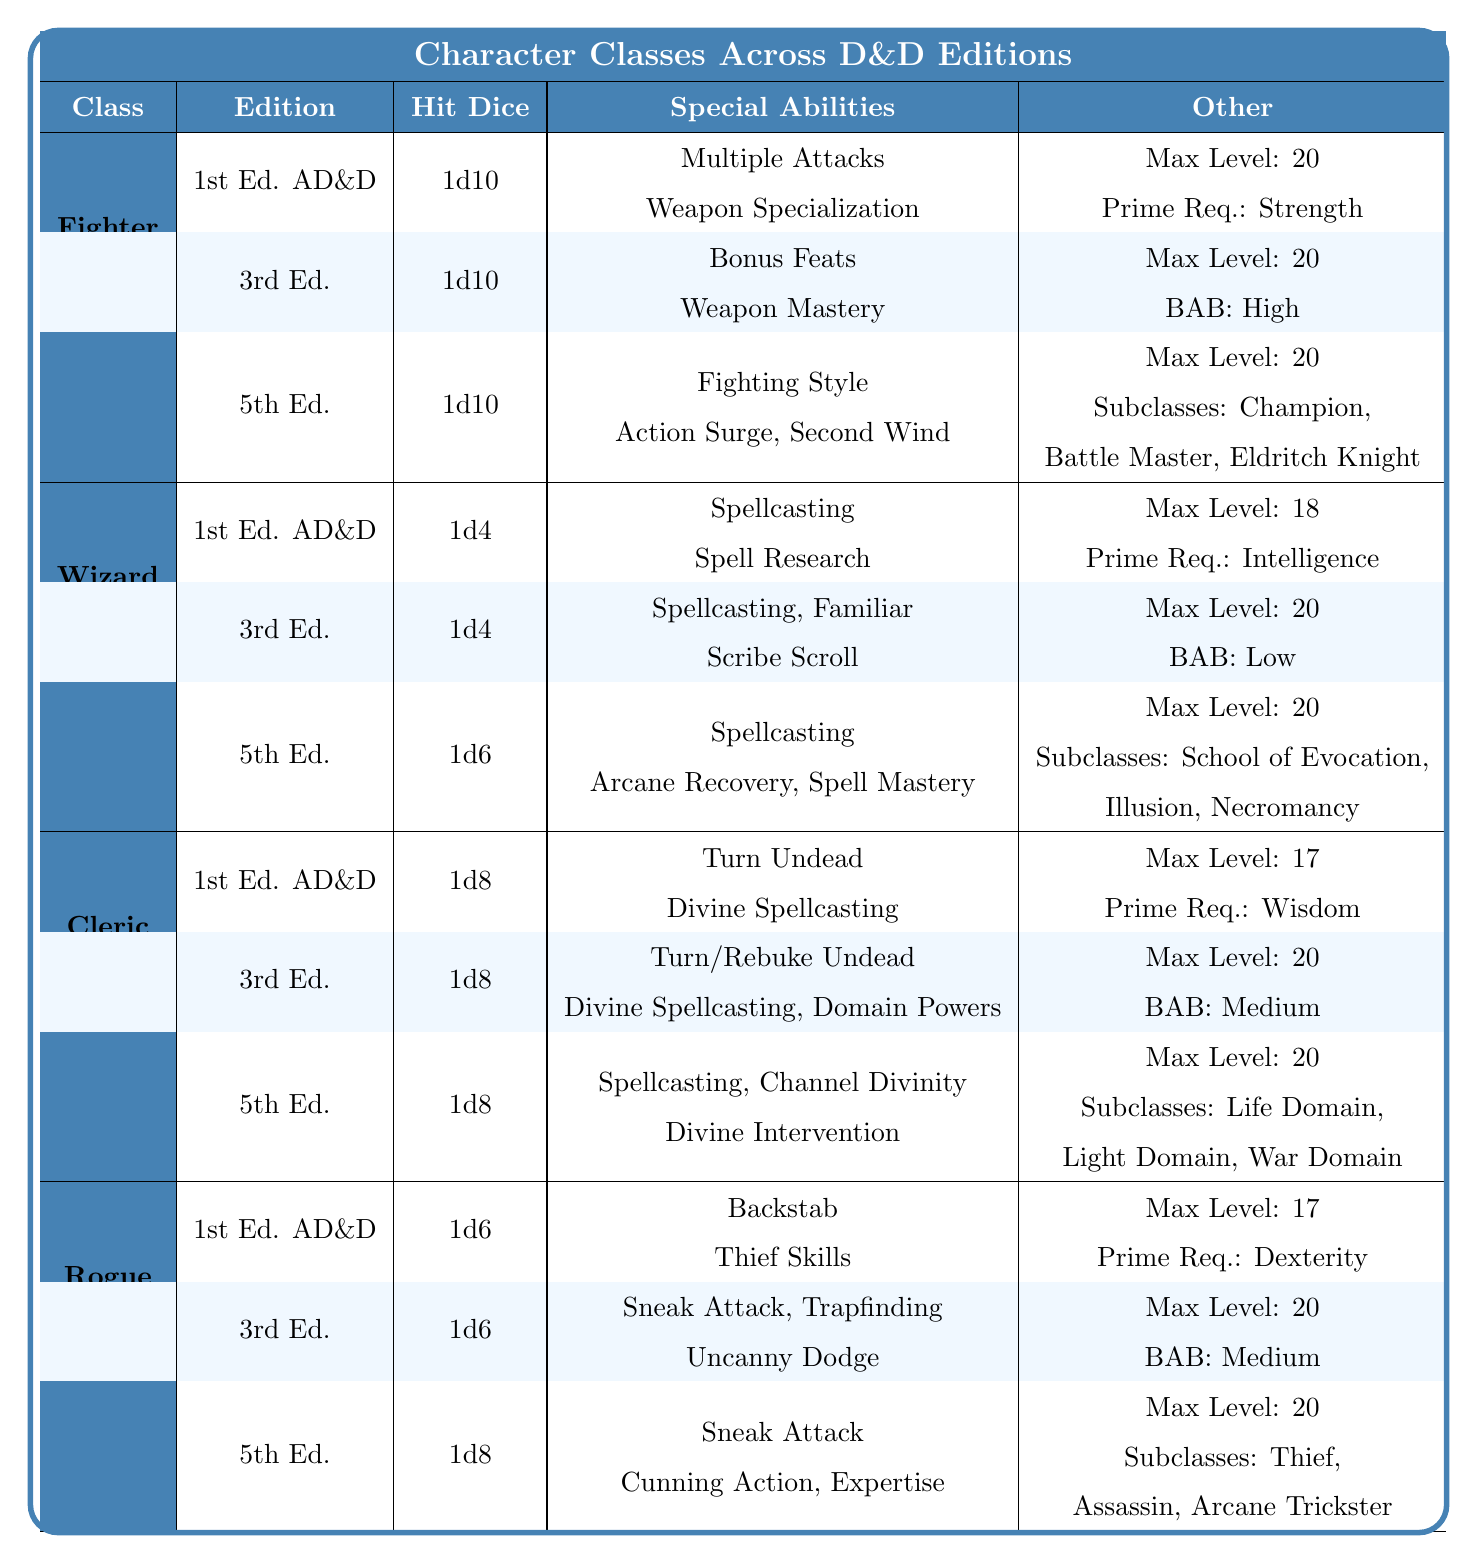What is the maximum level for a Fighter in 5th Edition? According to the table, the maximum level for a Fighter in 5th Edition is stated under "Maximum Level," which is 20.
Answer: 20 What special abilities do Rogues have in 3rd Edition? The table lists the special abilities for Rogues in 3rd Edition as "Sneak Attack," "Trapfinding," and "Uncanny Dodge."
Answer: Sneak Attack, Trapfinding, Uncanny Dodge True or False: Wizards in 1st Edition AD&D have spellcasting as a special ability. The table shows that "Spellcasting" is indeed listed as a special ability for Wizards in 1st Edition AD&D. Therefore, the statement is true.
Answer: True How does the Hit Die of a Cleric compare between 1st Edition and 5th Edition? For Clerics, the Hit Die in 1st Edition AD&D is 1d8, while in 5th Edition it remains 1d8. This means there is no difference in the Hit Die between these editions.
Answer: No difference Which character class has the highest maximum level across all editions? The table shows that Fighters in both 1st and 3rd Editions and Wizards and Rogues in 3rd Edition have a maximum level of 20, while Clerics in 1st Edition have a maximum of 17. Therefore, Fighters, Wizards, and Rogues can be considered as having the highest maximum level of 20 across all editions.
Answer: Fighters, Wizards, and Rogues have 20 What is the Prime Requisite for a Wizard in 1st Edition AD&D? The table specifies that the Prime Requisite for Wizards in 1st Edition AD&D is "Intelligence" under the "Other" column.
Answer: Intelligence If a Fighter can have three subclasses in 5th Edition, how many subclasses do Clerics have in the same edition? The table indicates that Fighters have three subclasses in 5th Edition while Clerics have three subclasses as well. Therefore, both classes have the same number of subclasses in 5th Edition.
Answer: Three subclasses Which class has a higher Hit Die in 5th Edition: Rogue or Wizard? In 5th Edition, the Hit Die for Rogues is listed as 1d8, while for Wizards it is 1d6. Since 1d8 represents a larger die size than 1d6, Rogues have a higher Hit Die than Wizards in 5th Edition.
Answer: Rogue has a higher Hit Die List the special abilities of a Fighter in 3rd Edition. The table identifies the special abilities of Fighters in 3rd Edition as "Bonus Feats" and "Weapon Mastery."
Answer: Bonus Feats, Weapon Mastery How many total Hit Dice does the Fighter class have across all editions? The table shows that Fighters have a Hit Die of 1d10 in both 1st and 3rd Editions, and 1d10 in 5th Edition as well. Hence, the total remains 1d10, as each edition keeps the Hit Die consistent.
Answer: 1d10 What are the differences in special abilities for Clerics between 3rd Edition and 5th Edition? The table lists Clerics in 3rd Edition with "Turn/Rebuke Undead," "Divine Spellcasting," and "Domain Powers," whereas in 5th Edition, they have "Spellcasting," "Channel Divinity," and "Divine Intervention." Thus, while both editions involve spellcasting, their unique abilities differ.
Answer: Different abilities 